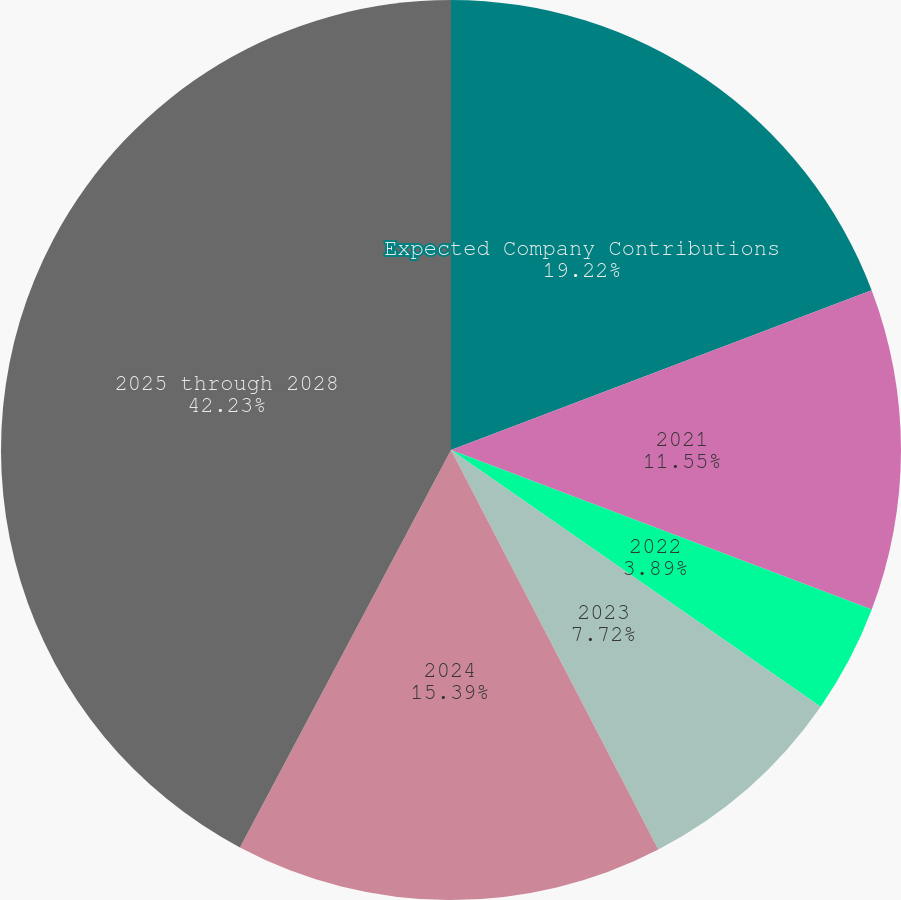Convert chart. <chart><loc_0><loc_0><loc_500><loc_500><pie_chart><fcel>Expected Company Contributions<fcel>2021<fcel>2022<fcel>2023<fcel>2024<fcel>2025 through 2028<nl><fcel>19.22%<fcel>11.55%<fcel>3.89%<fcel>7.72%<fcel>15.39%<fcel>42.23%<nl></chart> 